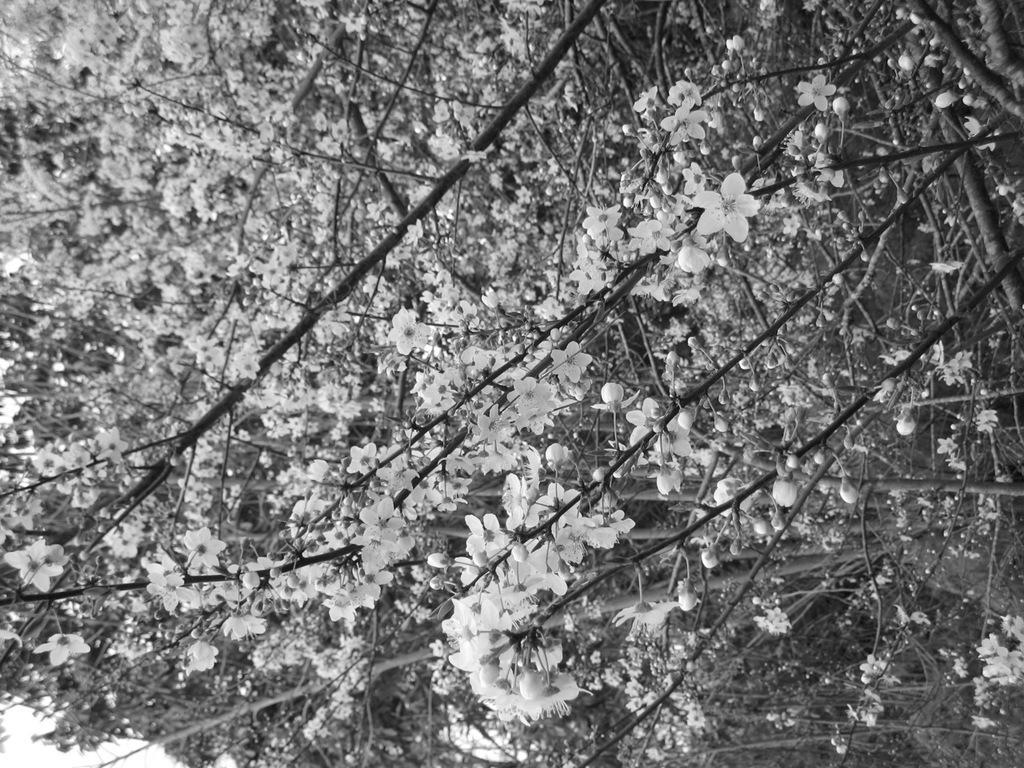How would you summarize this image in a sentence or two? In this picture we can see flowers and trees. 